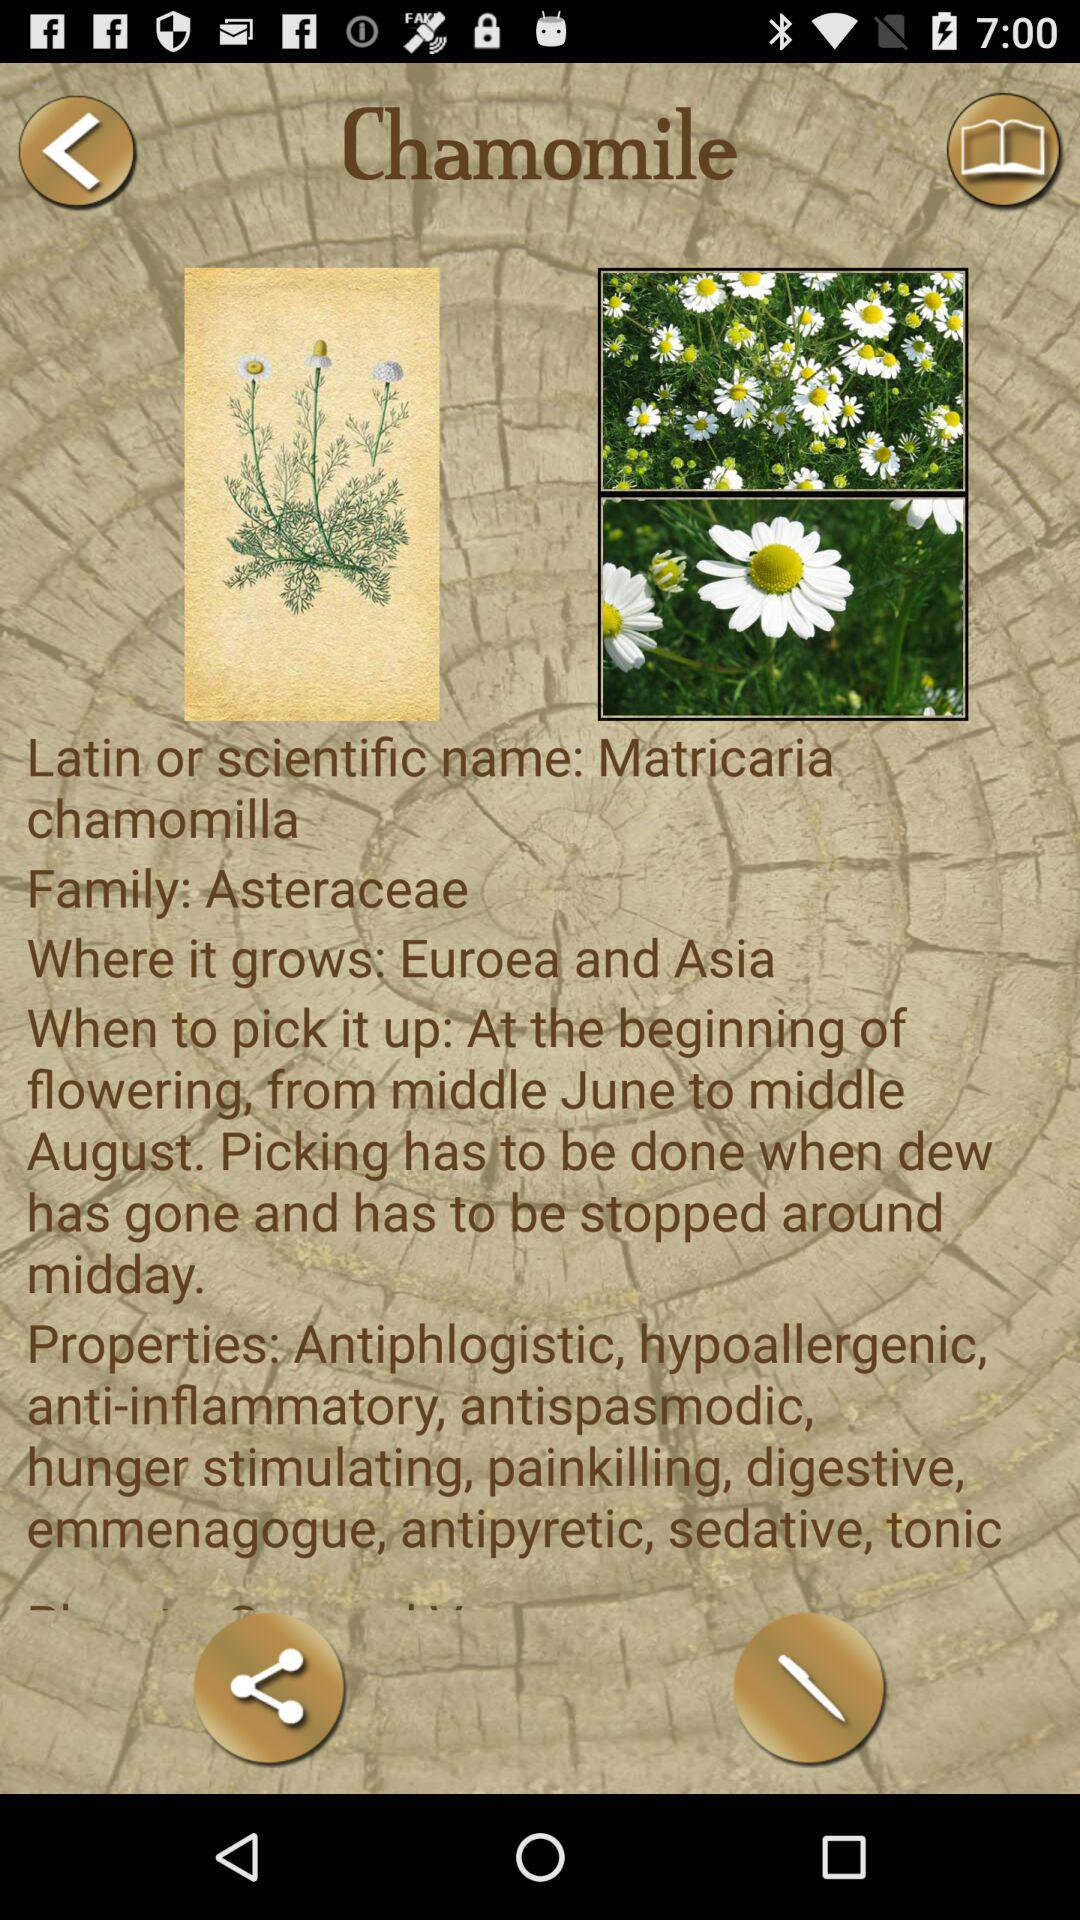Where does "Chamomile" grow? Chamomile grows in Euroea and Asia. 